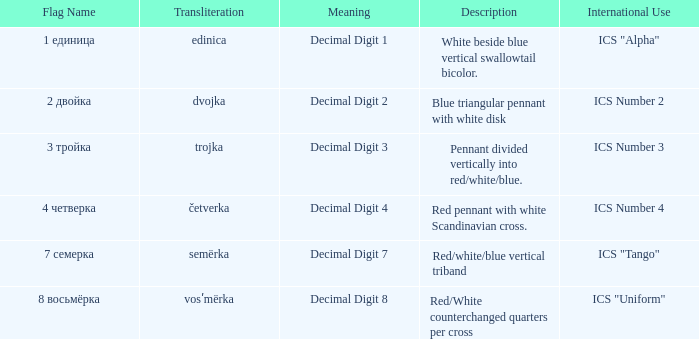What is the international use of the 1 единица flag? ICS "Alpha". 